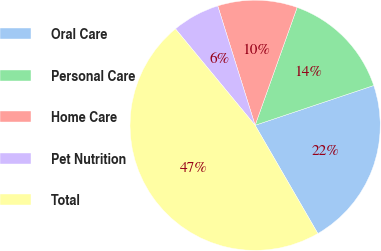Convert chart to OTSL. <chart><loc_0><loc_0><loc_500><loc_500><pie_chart><fcel>Oral Care<fcel>Personal Care<fcel>Home Care<fcel>Pet Nutrition<fcel>Total<nl><fcel>21.79%<fcel>14.4%<fcel>10.28%<fcel>6.16%<fcel>47.37%<nl></chart> 